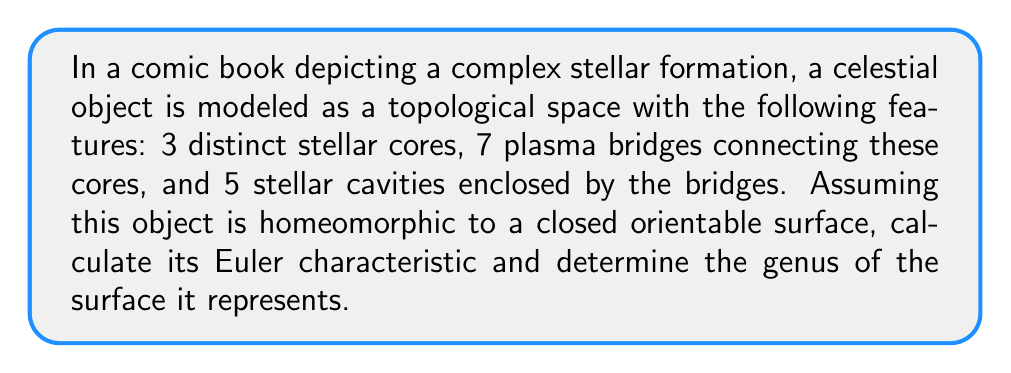Could you help me with this problem? To solve this problem, we'll use the Euler characteristic formula and its relationship to the genus of a surface. Let's break it down step-by-step:

1) The Euler characteristic $\chi$ is defined as:

   $$\chi = V - E + F$$

   Where:
   $V$ = number of vertices (stellar cores in this case)
   $E$ = number of edges (plasma bridges)
   $F$ = number of faces (stellar cavities + the outer face)

2) From the given information:
   $V = 3$ (stellar cores)
   $E = 7$ (plasma bridges)
   $F = 5 + 1 = 6$ (5 stellar cavities + 1 outer face)

3) Substituting these values into the Euler characteristic formula:

   $$\chi = 3 - 7 + 6 = 2$$

4) For a closed orientable surface, the Euler characteristic is related to the genus $g$ by the formula:

   $$\chi = 2 - 2g$$

5) We can solve this for $g$:

   $$2 = 2 - 2g$$
   $$2g = 0$$
   $$g = 0$$

6) A genus of 0 corresponds to a topological sphere.

This result indicates that despite its complex appearance, the stellar formation is topologically equivalent to a sphere, which is consistent with many celestial objects that maintain a generally spherical shape due to gravity.
Answer: The Euler characteristic of the complex stellar formation is $\chi = 2$, and it represents a surface with genus $g = 0$, topologically equivalent to a sphere. 